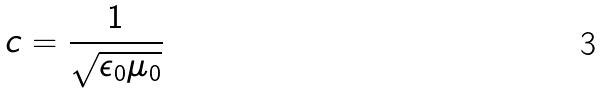<formula> <loc_0><loc_0><loc_500><loc_500>c = \frac { 1 } { \sqrt { \epsilon _ { 0 } \mu _ { 0 } } }</formula> 